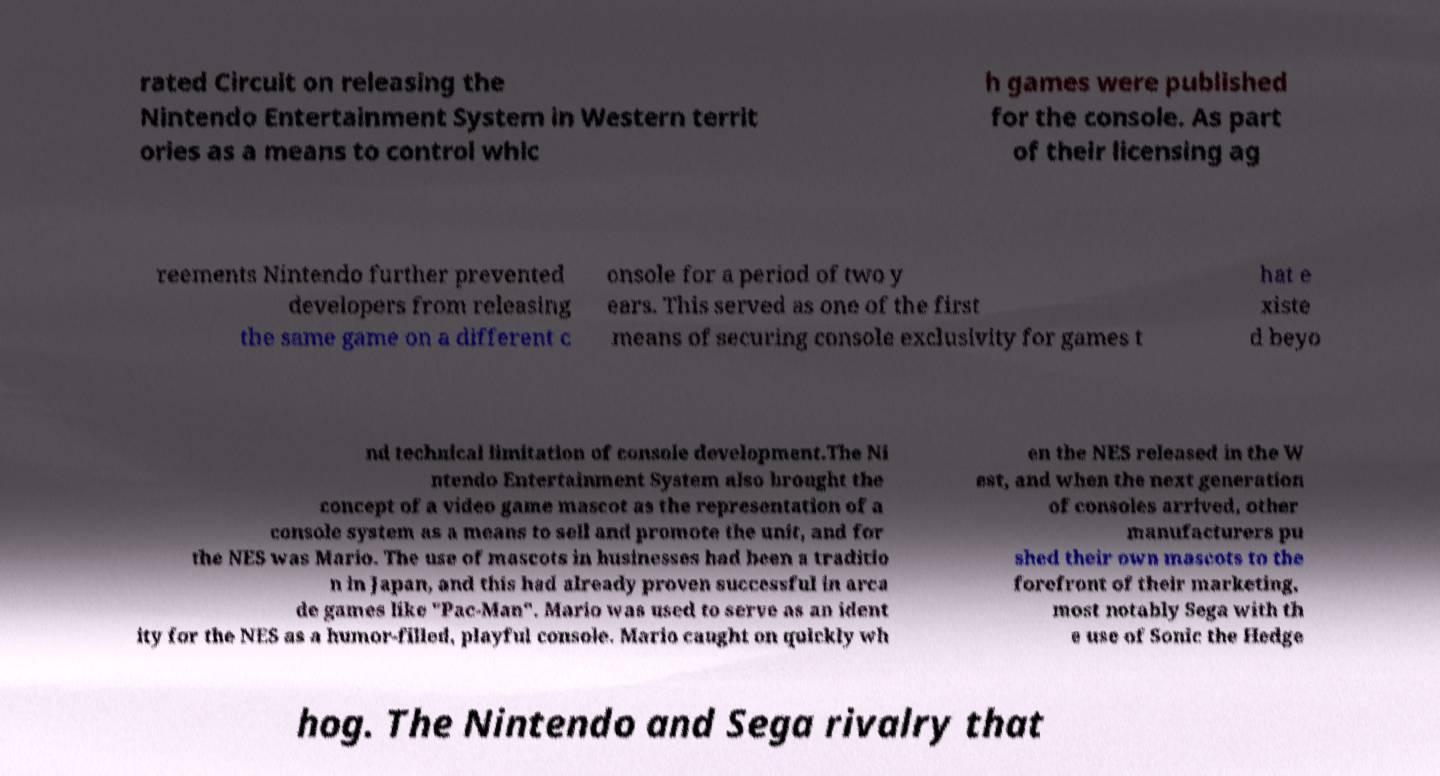I need the written content from this picture converted into text. Can you do that? rated Circuit on releasing the Nintendo Entertainment System in Western territ ories as a means to control whic h games were published for the console. As part of their licensing ag reements Nintendo further prevented developers from releasing the same game on a different c onsole for a period of two y ears. This served as one of the first means of securing console exclusivity for games t hat e xiste d beyo nd technical limitation of console development.The Ni ntendo Entertainment System also brought the concept of a video game mascot as the representation of a console system as a means to sell and promote the unit, and for the NES was Mario. The use of mascots in businesses had been a traditio n in Japan, and this had already proven successful in arca de games like "Pac-Man". Mario was used to serve as an ident ity for the NES as a humor-filled, playful console. Mario caught on quickly wh en the NES released in the W est, and when the next generation of consoles arrived, other manufacturers pu shed their own mascots to the forefront of their marketing, most notably Sega with th e use of Sonic the Hedge hog. The Nintendo and Sega rivalry that 